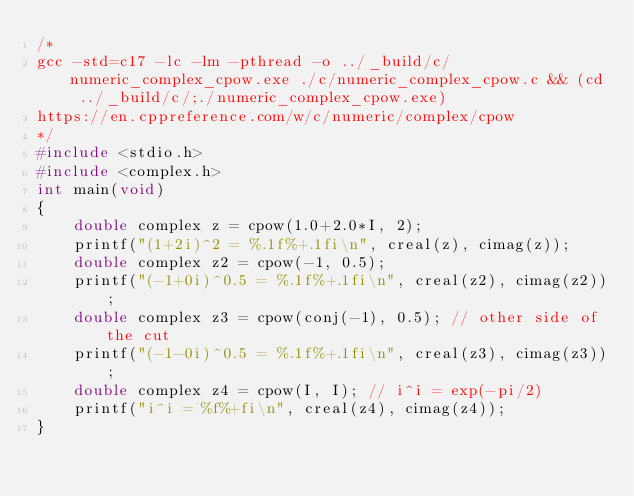<code> <loc_0><loc_0><loc_500><loc_500><_C_>/*
gcc -std=c17 -lc -lm -pthread -o ../_build/c/numeric_complex_cpow.exe ./c/numeric_complex_cpow.c && (cd ../_build/c/;./numeric_complex_cpow.exe)
https://en.cppreference.com/w/c/numeric/complex/cpow
*/
#include <stdio.h>
#include <complex.h>
int main(void)
{    
    double complex z = cpow(1.0+2.0*I, 2);
    printf("(1+2i)^2 = %.1f%+.1fi\n", creal(z), cimag(z));
    double complex z2 = cpow(-1, 0.5);
    printf("(-1+0i)^0.5 = %.1f%+.1fi\n", creal(z2), cimag(z2));
    double complex z3 = cpow(conj(-1), 0.5); // other side of the cut
    printf("(-1-0i)^0.5 = %.1f%+.1fi\n", creal(z3), cimag(z3));
    double complex z4 = cpow(I, I); // i^i = exp(-pi/2)
    printf("i^i = %f%+fi\n", creal(z4), cimag(z4));
}

</code> 